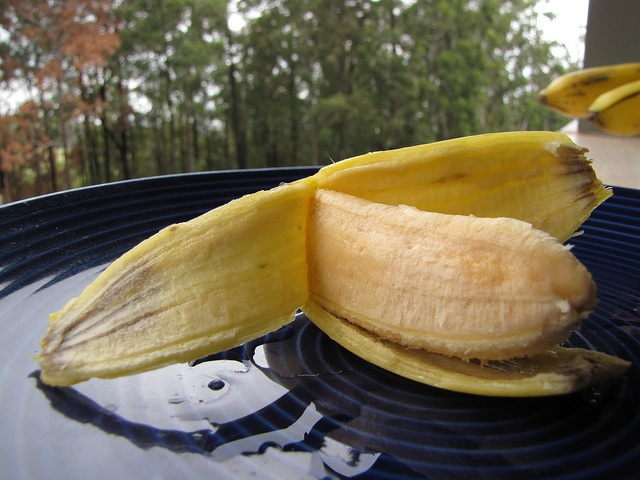Describe the objects in this image and their specific colors. I can see banana in black, olive, and tan tones and banana in black, olive, and tan tones in this image. 